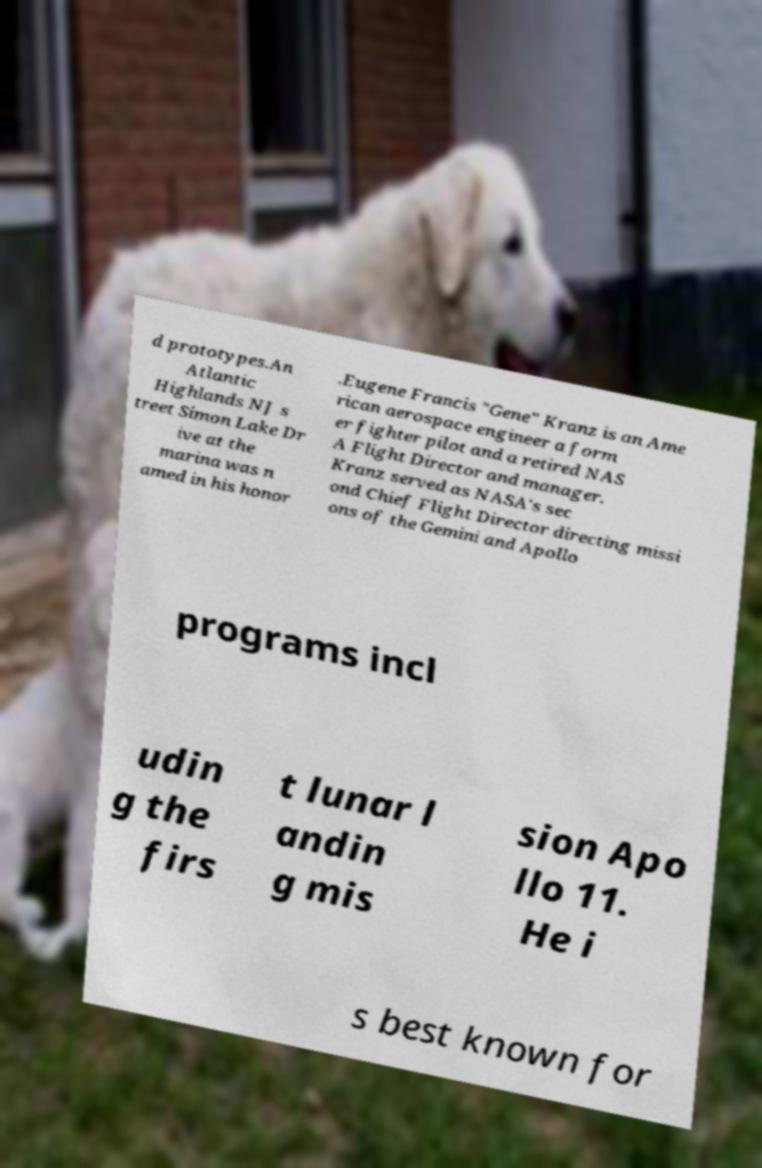Could you extract and type out the text from this image? d prototypes.An Atlantic Highlands NJ s treet Simon Lake Dr ive at the marina was n amed in his honor .Eugene Francis "Gene" Kranz is an Ame rican aerospace engineer a form er fighter pilot and a retired NAS A Flight Director and manager. Kranz served as NASA's sec ond Chief Flight Director directing missi ons of the Gemini and Apollo programs incl udin g the firs t lunar l andin g mis sion Apo llo 11. He i s best known for 